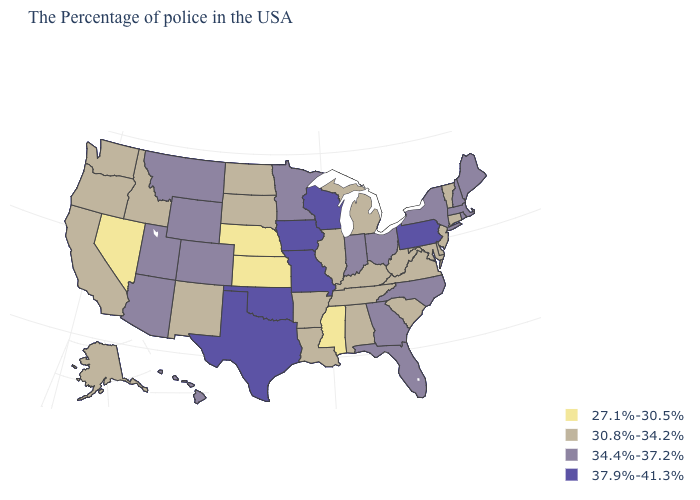Does the first symbol in the legend represent the smallest category?
Keep it brief. Yes. What is the value of Arizona?
Concise answer only. 34.4%-37.2%. Name the states that have a value in the range 30.8%-34.2%?
Keep it brief. Vermont, Connecticut, New Jersey, Delaware, Maryland, Virginia, South Carolina, West Virginia, Michigan, Kentucky, Alabama, Tennessee, Illinois, Louisiana, Arkansas, South Dakota, North Dakota, New Mexico, Idaho, California, Washington, Oregon, Alaska. What is the value of Oklahoma?
Quick response, please. 37.9%-41.3%. What is the highest value in states that border South Dakota?
Write a very short answer. 37.9%-41.3%. Among the states that border Delaware , which have the lowest value?
Keep it brief. New Jersey, Maryland. What is the value of West Virginia?
Concise answer only. 30.8%-34.2%. Is the legend a continuous bar?
Answer briefly. No. What is the value of North Dakota?
Answer briefly. 30.8%-34.2%. Does Mississippi have the lowest value in the South?
Short answer required. Yes. What is the highest value in the MidWest ?
Keep it brief. 37.9%-41.3%. Which states have the lowest value in the West?
Answer briefly. Nevada. What is the value of Florida?
Be succinct. 34.4%-37.2%. Does the first symbol in the legend represent the smallest category?
Answer briefly. Yes. Is the legend a continuous bar?
Short answer required. No. 